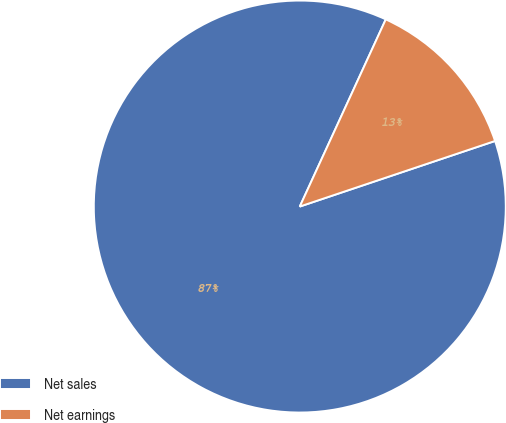Convert chart. <chart><loc_0><loc_0><loc_500><loc_500><pie_chart><fcel>Net sales<fcel>Net earnings<nl><fcel>87.01%<fcel>12.99%<nl></chart> 